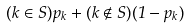Convert formula to latex. <formula><loc_0><loc_0><loc_500><loc_500>( k \in S ) p _ { k } + ( k \notin S ) ( 1 - p _ { k } )</formula> 